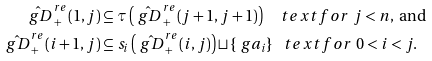Convert formula to latex. <formula><loc_0><loc_0><loc_500><loc_500>\hat { \ g D } _ { + } ^ { r e } ( 1 , j ) & \subseteq \tau \left ( \hat { \ g D } _ { + } ^ { r e } ( j + 1 , j + 1 ) \right ) \quad t e x t { f o r } \ j < n , \ \text {and} \\ \hat { \ g D } _ { + } ^ { r e } ( i + 1 , j ) & \subseteq s _ { i } \left ( \hat { \ g D } _ { + } ^ { r e } ( i , j ) \right ) \sqcup \{ \ g a _ { i } \} \ \ \ t e x t { f o r } \ 0 < i < j .</formula> 